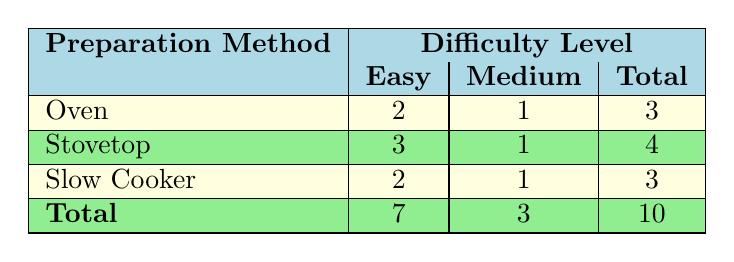What is the total number of easy recipes? To find the total number of easy recipes, I will look at the easy column in the table. The stove top has 3 easy recipes, the oven has 2 easy recipes, and the slow cooker has 2 easy recipes. Adding these together gives: 3 + 2 + 2 = 7
Answer: 7 How many medium difficulty recipes are prepared using the stovetop? I will examine the medium column under the stovetop row in the table. It shows there's 1 medium difficulty recipe for the stovetop.
Answer: 1 Is there a slow cooker recipe that is classified as easy? Yes, I can see that in the table, there are 2 easy recipes listed under the slow cooker.
Answer: Yes What is the difference in the total number of easy and medium recipes? To answer this, I will first calculate the total number of easy recipes which is 7, and the total number of medium recipes which is 3. The difference is calculated as: 7 - 3 = 4
Answer: 4 What preparation method has the highest number of total recipes? I will compare the total values in the last row of the table: oven has 3, stovetop has 4, and slow cooker has 3. The highest number is from stovetop, which has 4 total recipes.
Answer: Stovetop How many recipes have an easy difficulty level but are not prepared in the oven? To find this, I look at the easy column excluding the oven row. Stovetop has 3 and slow cooker has 2, totaling to 5 easy recipes not prepared in the oven: 3 + 2 = 5.
Answer: 5 Is the average rating of easy recipes higher than that of medium recipes? I first total the ratings for easy recipes: (4.8 + 4.6 + 4.9 + 4.3 + 4.5 + 4.8) = 27.9 and divide by the number of easy recipes (7): 27.9/6 = 4.65. For medium ratings: (4.5 + 4.4 + 4.6) = 13.5 and divide by the number of medium recipes (3): 13.5/3 = 4.5. Comparing, 4.65 is greater than 4.5.
Answer: Yes What is the total count of easy recipes across all preparation methods? I sum up the easy recipes listed under each preparation method: 2 (oven) + 3 (stovetop) + 2 (slow cooker) = 7
Answer: 7 Are there more recipes prepared in the oven or the slow cooker? The oven has 3 total recipes and the slow cooker also has 3. Since both are equal, there are not more in either method.
Answer: No 